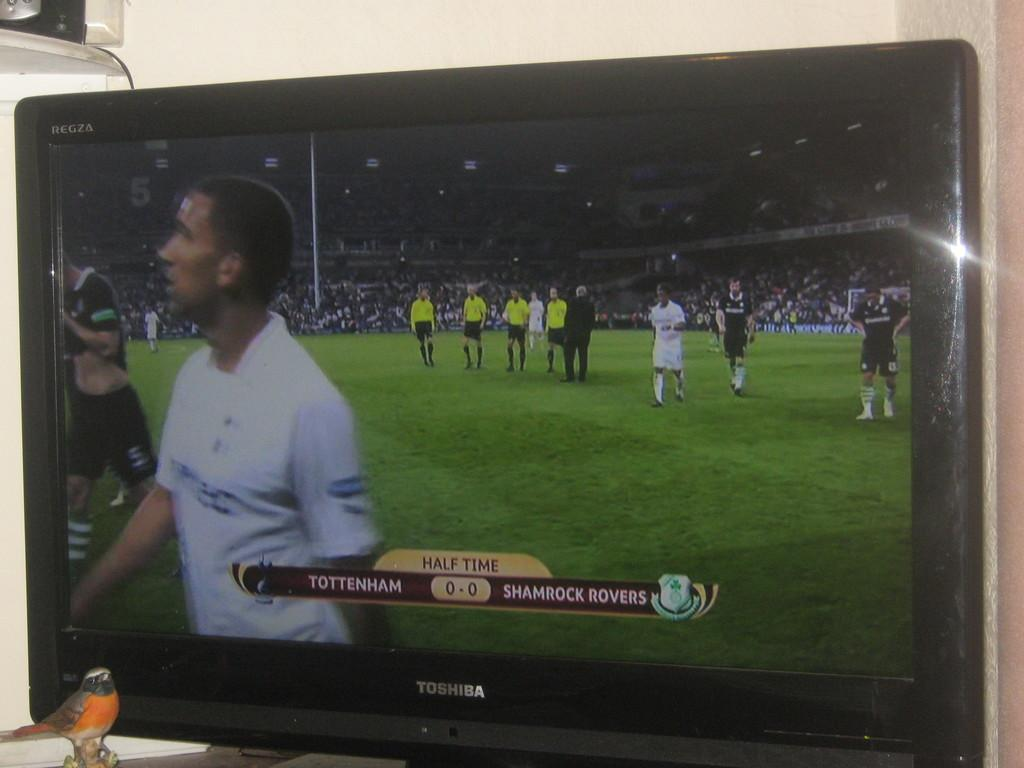<image>
Relay a brief, clear account of the picture shown. The game between Tottenham and the Shamrock Rovers is tied at 0 